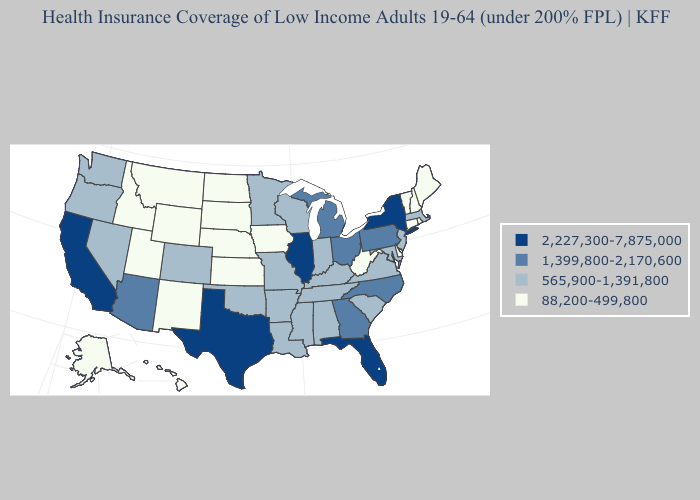What is the highest value in states that border Wyoming?
Give a very brief answer. 565,900-1,391,800. Among the states that border Rhode Island , does Massachusetts have the lowest value?
Keep it brief. No. Name the states that have a value in the range 88,200-499,800?
Quick response, please. Alaska, Connecticut, Delaware, Hawaii, Idaho, Iowa, Kansas, Maine, Montana, Nebraska, New Hampshire, New Mexico, North Dakota, Rhode Island, South Dakota, Utah, Vermont, West Virginia, Wyoming. Name the states that have a value in the range 88,200-499,800?
Be succinct. Alaska, Connecticut, Delaware, Hawaii, Idaho, Iowa, Kansas, Maine, Montana, Nebraska, New Hampshire, New Mexico, North Dakota, Rhode Island, South Dakota, Utah, Vermont, West Virginia, Wyoming. What is the highest value in the Northeast ?
Write a very short answer. 2,227,300-7,875,000. What is the value of North Carolina?
Keep it brief. 1,399,800-2,170,600. What is the value of Alabama?
Answer briefly. 565,900-1,391,800. Name the states that have a value in the range 565,900-1,391,800?
Keep it brief. Alabama, Arkansas, Colorado, Indiana, Kentucky, Louisiana, Maryland, Massachusetts, Minnesota, Mississippi, Missouri, Nevada, New Jersey, Oklahoma, Oregon, South Carolina, Tennessee, Virginia, Washington, Wisconsin. Is the legend a continuous bar?
Quick response, please. No. Name the states that have a value in the range 88,200-499,800?
Give a very brief answer. Alaska, Connecticut, Delaware, Hawaii, Idaho, Iowa, Kansas, Maine, Montana, Nebraska, New Hampshire, New Mexico, North Dakota, Rhode Island, South Dakota, Utah, Vermont, West Virginia, Wyoming. What is the value of Idaho?
Quick response, please. 88,200-499,800. What is the highest value in the Northeast ?
Keep it brief. 2,227,300-7,875,000. Which states have the lowest value in the South?
Short answer required. Delaware, West Virginia. Does New Hampshire have the lowest value in the Northeast?
Quick response, please. Yes. How many symbols are there in the legend?
Give a very brief answer. 4. 